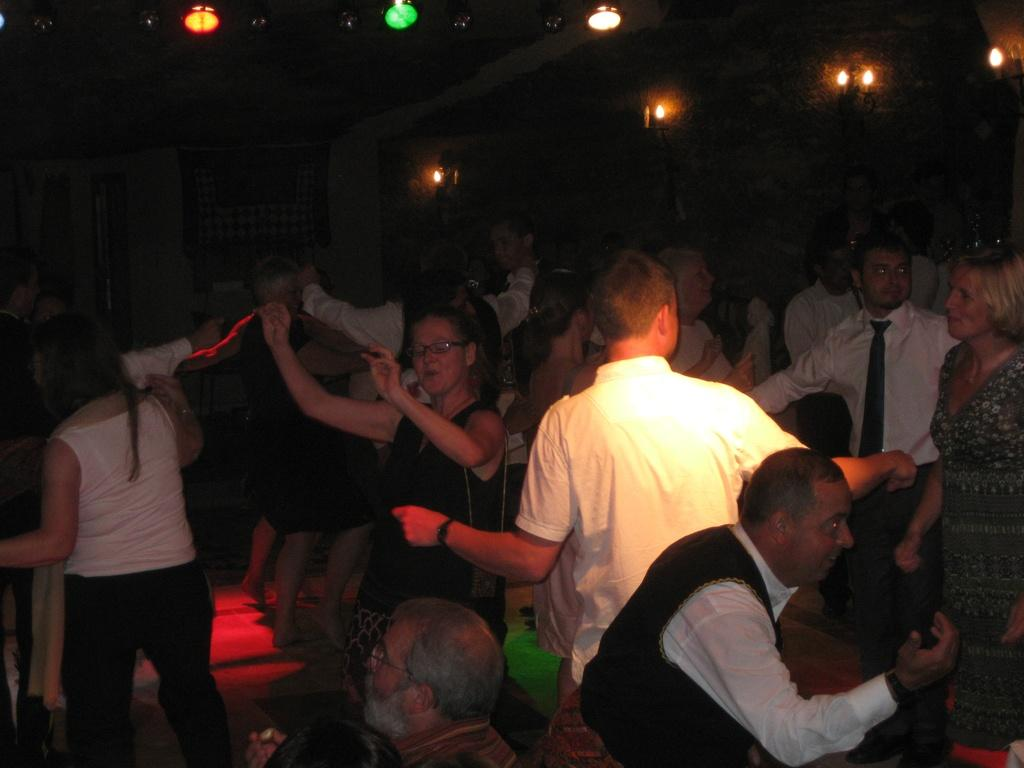What type of event is taking place in the image? It is a party. What are the people at the party doing? People are enjoying the music and dancing on the floor. Can you describe the lighting in the room? There are different types of lights in the room. How is the room illuminated during the party? The room is dark, but the different types of lights provide illumination. What type of brick is being used to build the engine in the image? There is no brick or engine present in the image; it is a party scene with people dancing and enjoying music. 